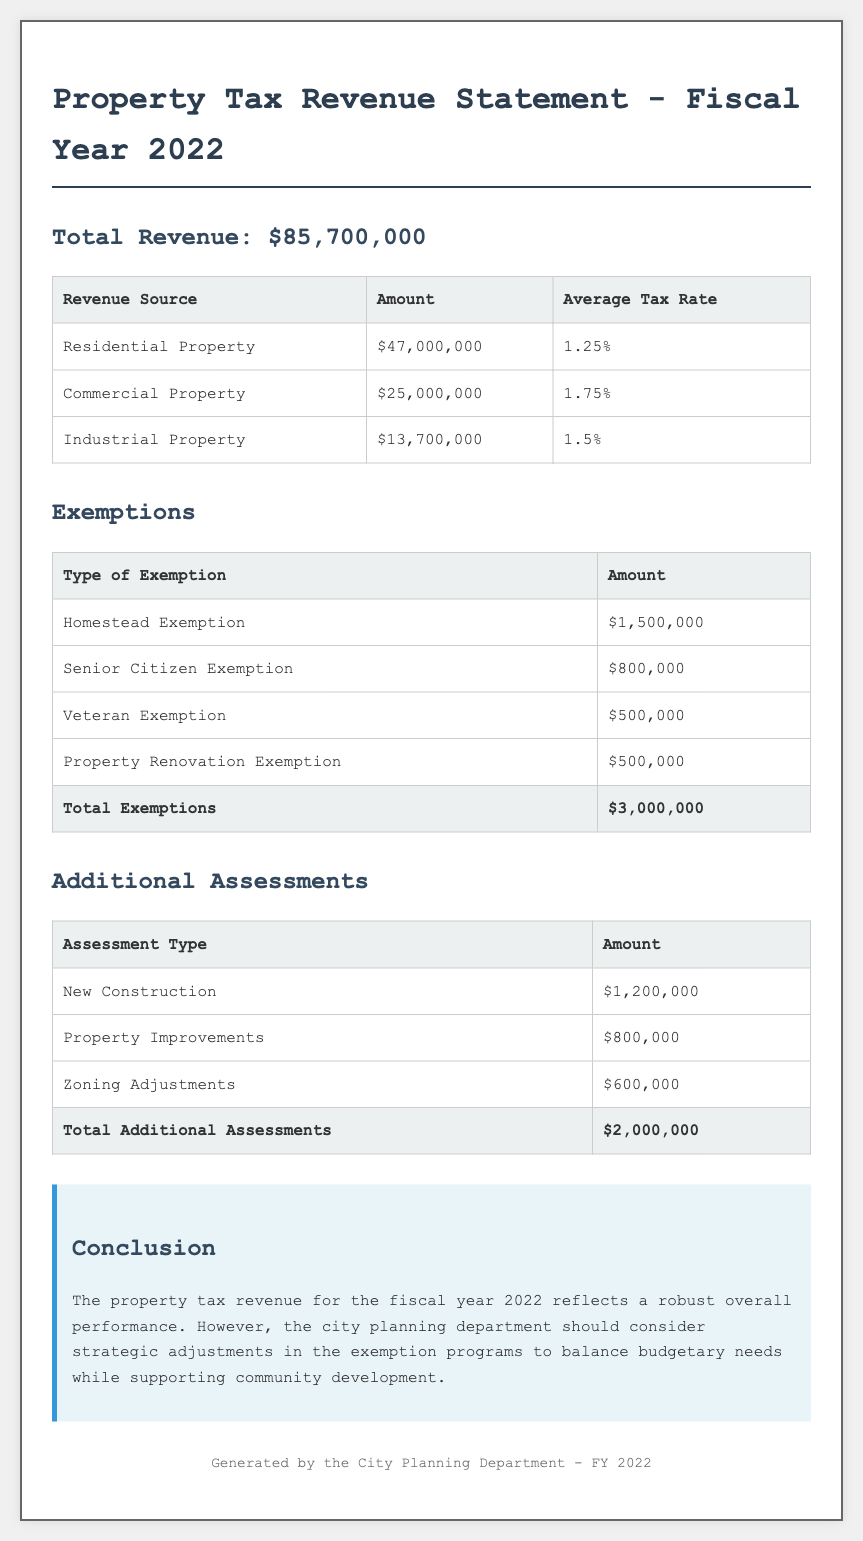What is the total revenue? The total revenue is stated at the beginning of the document, showing the overall amount collected for the fiscal year 2022.
Answer: $85,700,000 How much revenue comes from residential property? This value is found in the revenue sources table, specifically under the residential property category.
Answer: $47,000,000 What is the average tax rate for commercial property? The average tax rate is detailed in the revenue sources table alongside the commercial property revenue.
Answer: 1.75% What is the total amount of exemptions? The total exemptions are listed in the exemptions table, summarizing all types of exemptions given in the fiscal year 2022.
Answer: $3,000,000 How much revenue was gained from new construction assessments? This amount is found under the additional assessments section, specifically for the new construction category.
Answer: $1,200,000 Which exemption type has the highest amount? The highest amount can be determined by comparing the values in the exemptions table, showing each exemption type.
Answer: Homestead Exemption What is the total amount for additional assessments? This total is summarized at the end of the additional assessments table, indicating the overall amount of assessments added.
Answer: $2,000,000 What does the conclusion suggest about exemption programs? The conclusion offers advice related to the exemption programs based on the property tax revenue performance mentioned.
Answer: Strategic adjustments What are the two types of additional assessments listed? This question asks for specific types within the additional assessments section, which include various categories.
Answer: New Construction, Property Improvements What department generated this document? This detail is located in the footer of the document, indicating which municipal department produced the statement.
Answer: City Planning Department 